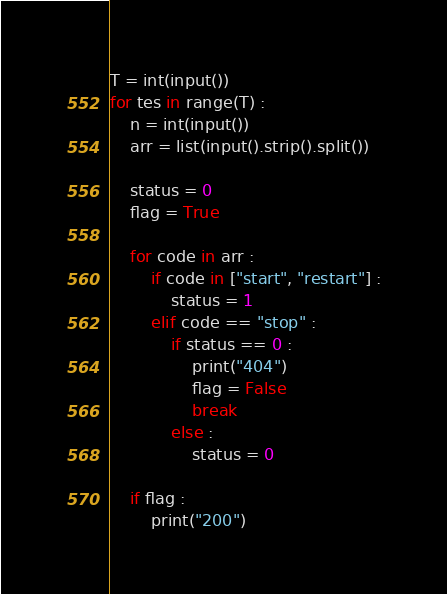Convert code to text. <code><loc_0><loc_0><loc_500><loc_500><_Python_>T = int(input())
for tes in range(T) :
    n = int(input())
    arr = list(input().strip().split())

    status = 0
    flag = True

    for code in arr :
        if code in ["start", "restart"] :
            status = 1
        elif code == "stop" :
            if status == 0 :
                print("404")
                flag = False
                break
            else :
                status = 0
    
    if flag :
        print("200")
</code> 